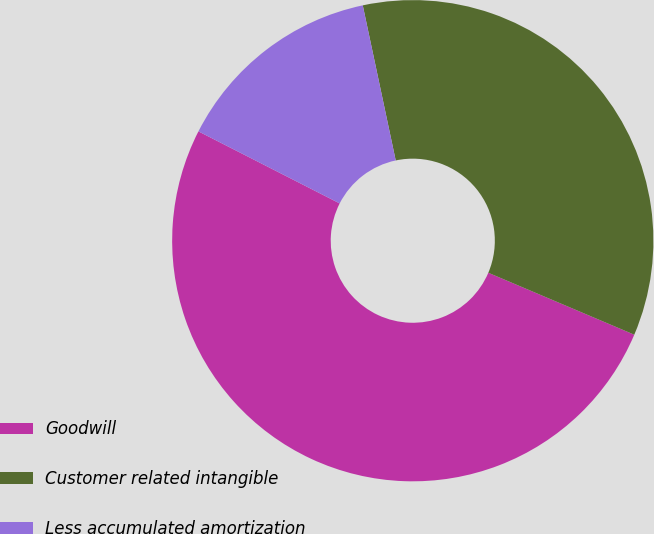<chart> <loc_0><loc_0><loc_500><loc_500><pie_chart><fcel>Goodwill<fcel>Customer related intangible<fcel>Less accumulated amortization<nl><fcel>51.12%<fcel>34.72%<fcel>14.16%<nl></chart> 